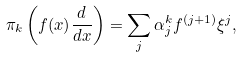<formula> <loc_0><loc_0><loc_500><loc_500>\pi _ { k } \left ( f ( x ) \frac { d } { d x } \right ) = \sum _ { j } \alpha ^ { k } _ { j } f ^ { ( j + 1 ) } \xi ^ { j } ,</formula> 